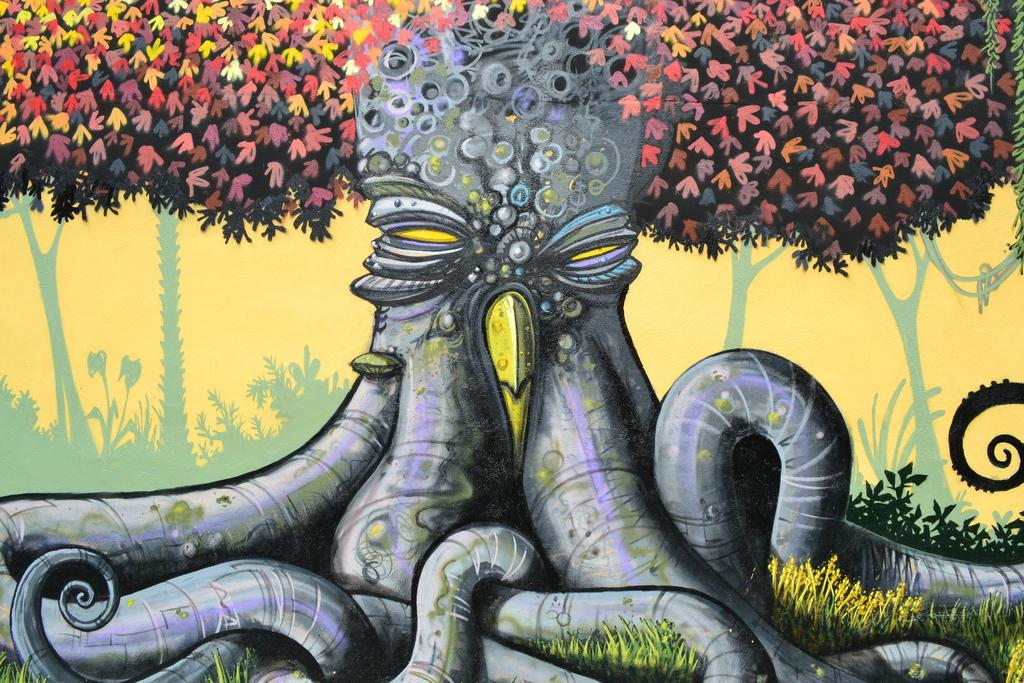What is depicted in the image? There is a painting of a tree in the image. What type of pollution can be seen affecting the tree in the image? There is no pollution present in the image; it is a painting of a tree. What type of quartz is visible in the image? There is no quartz present in the image; it is a painting of a tree. 